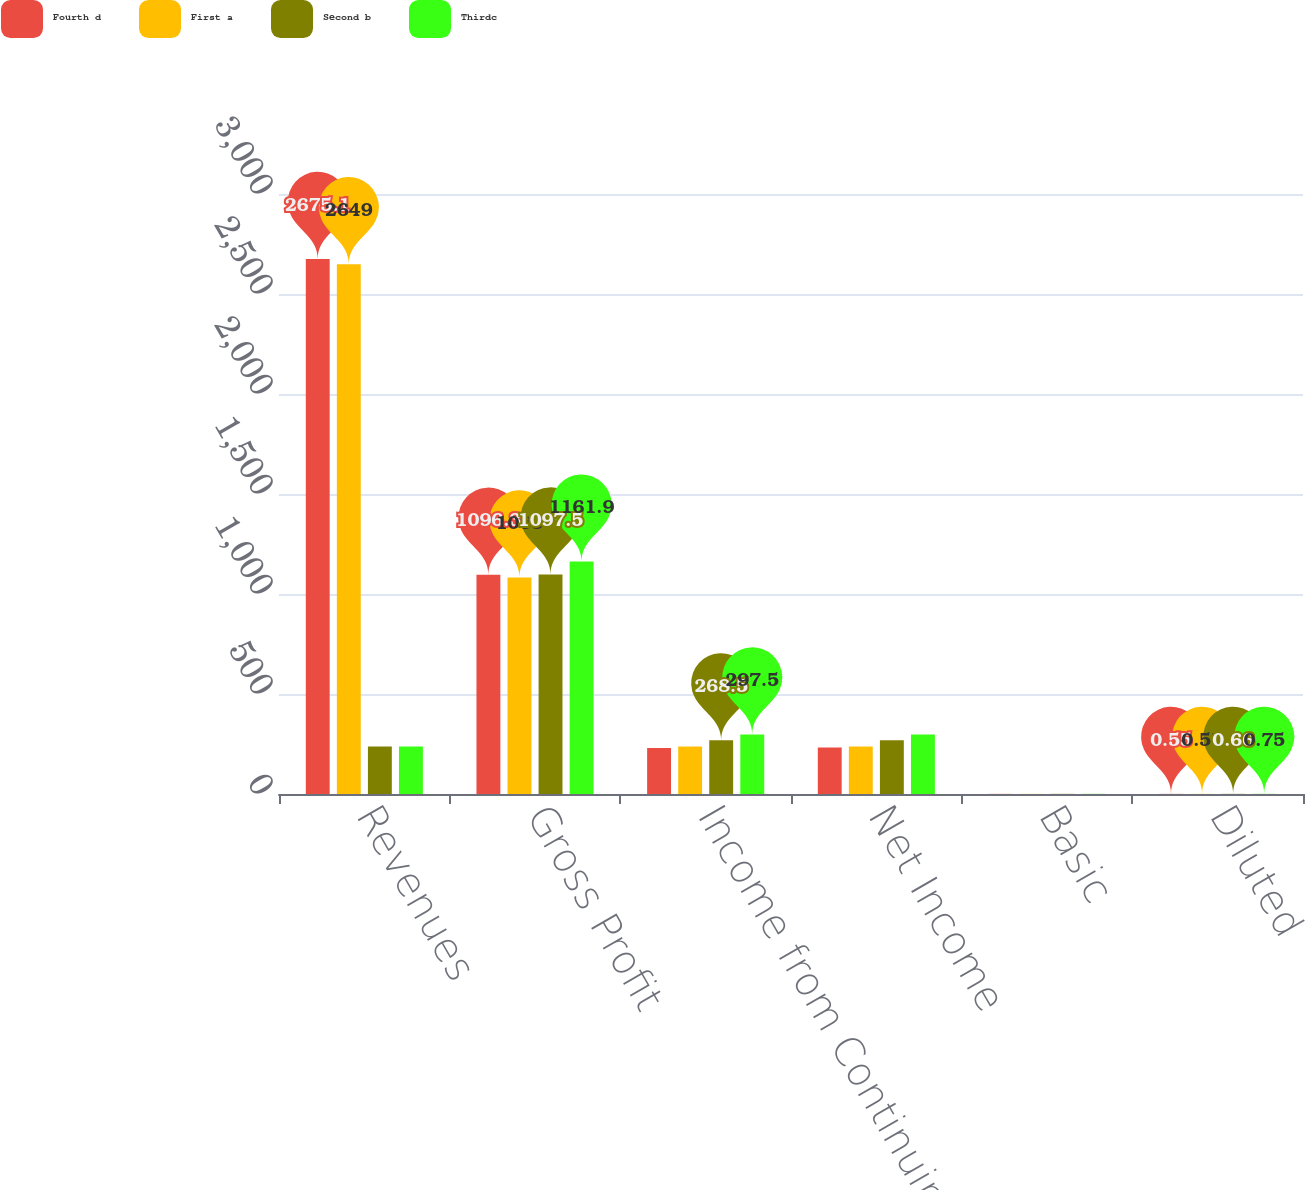Convert chart to OTSL. <chart><loc_0><loc_0><loc_500><loc_500><stacked_bar_chart><ecel><fcel>Revenues<fcel>Gross Profit<fcel>Income from Continuing<fcel>Net Income<fcel>Basic<fcel>Diluted<nl><fcel>Fourth d<fcel>2675.1<fcel>1096.3<fcel>229.8<fcel>232.3<fcel>0.56<fcel>0.55<nl><fcel>First a<fcel>2649<fcel>1083<fcel>237.3<fcel>237.3<fcel>0.58<fcel>0.57<nl><fcel>Second b<fcel>237.3<fcel>1097.5<fcel>268.5<fcel>268.5<fcel>0.67<fcel>0.66<nl><fcel>Thirdc<fcel>237.3<fcel>1161.9<fcel>297.5<fcel>297.5<fcel>0.76<fcel>0.75<nl></chart> 